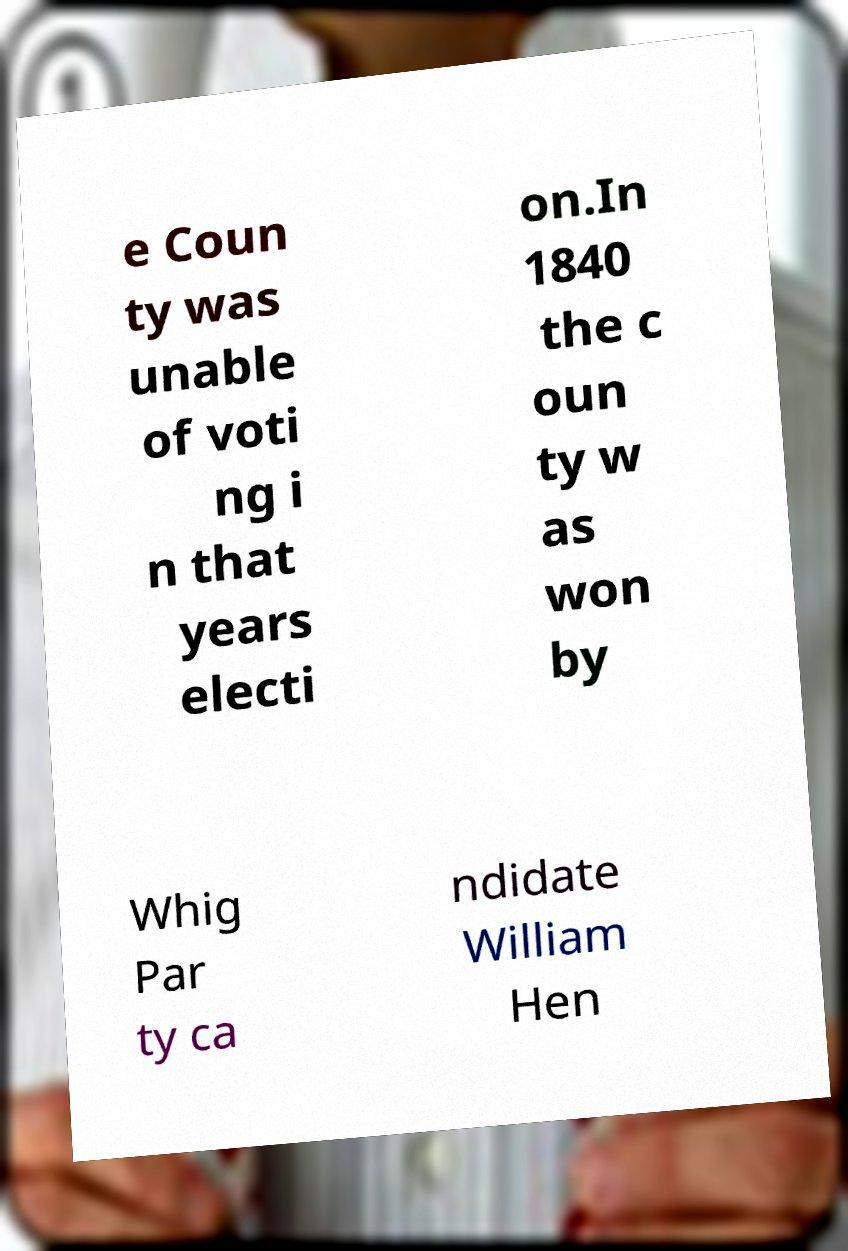Please identify and transcribe the text found in this image. e Coun ty was unable of voti ng i n that years electi on.In 1840 the c oun ty w as won by Whig Par ty ca ndidate William Hen 